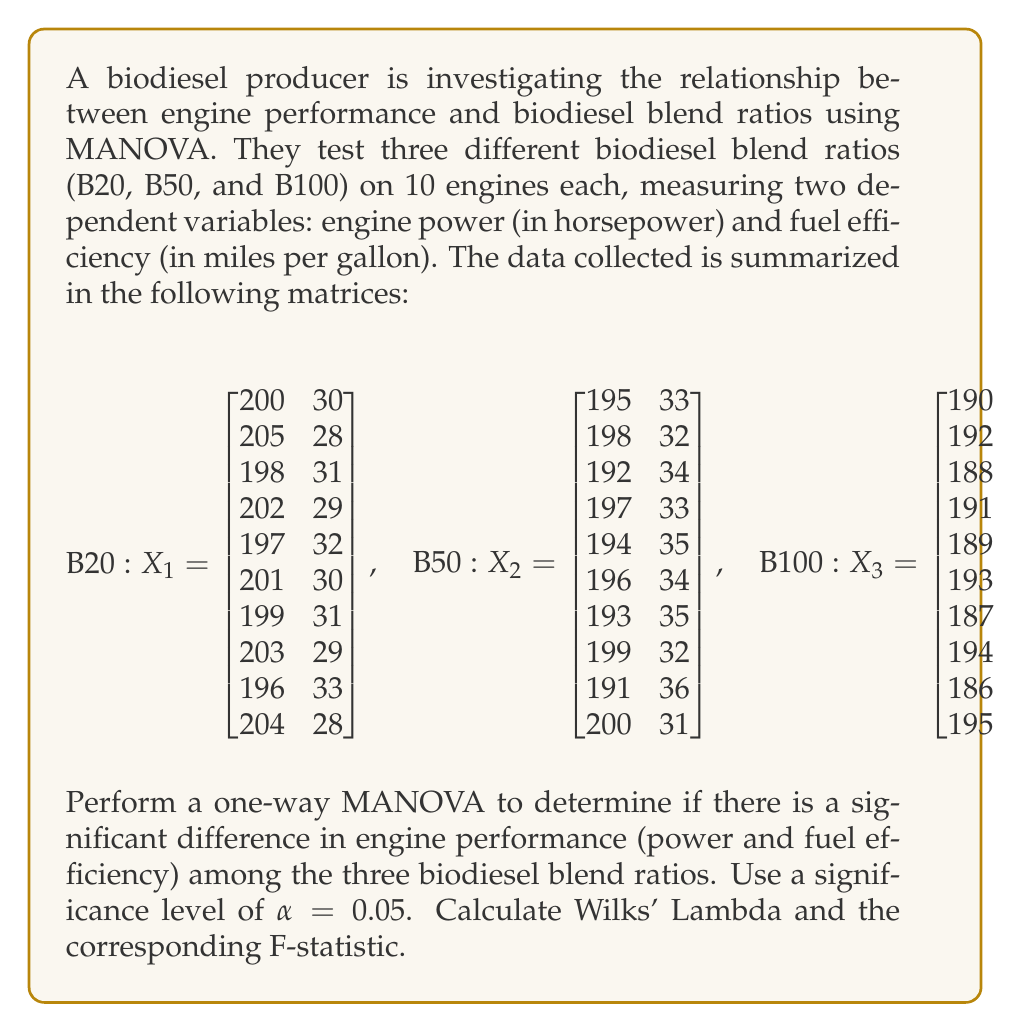Could you help me with this problem? To perform a one-way MANOVA, we need to follow these steps:

1. Calculate the within-group sum of squares and cross-products matrix (W)
2. Calculate the between-group sum of squares and cross-products matrix (B)
3. Calculate the total sum of squares and cross-products matrix (T)
4. Calculate Wilks' Lambda
5. Calculate the F-statistic
6. Compare the F-statistic to the critical value

Step 1: Calculate W

First, we need to calculate the mean vectors for each group:

$$\bar{X}_1 = \begin{bmatrix} 200.5 \\ 30.1 \end{bmatrix}, \quad
\bar{X}_2 = \begin{bmatrix} 195.5 \\ 33.5 \end{bmatrix}, \quad
\bar{X}_3 = \begin{bmatrix} 190.5 \\ 36.3 \end{bmatrix}$$

Now, we can calculate W:

$$W = \sum_{i=1}^3 \sum_{j=1}^{10} (X_{ij} - \bar{X}_i)(X_{ij} - \bar{X}_i)'$$

After calculations, we get:

$$W = \begin{bmatrix} 279.5 & -126.7 \\ -126.7 & 81.37 \end{bmatrix}$$

Step 2: Calculate B

Calculate the grand mean:

$$\bar{X} = \begin{bmatrix} 195.5 \\ 33.3 \end{bmatrix}$$

Now, calculate B:

$$B = \sum_{i=1}^3 10(\bar{X}_i - \bar{X})(\bar{X}_i - \bar{X})'$$

After calculations, we get:

$$B = \begin{bmatrix} 750 & -465 \\ -465 & 288.6 \end{bmatrix}$$

Step 3: Calculate T

$$T = W + B = \begin{bmatrix} 1029.5 & -591.7 \\ -591.7 & 369.97 \end{bmatrix}$$

Step 4: Calculate Wilks' Lambda

$$\Lambda = \frac{|W|}{|T|} = \frac{11424.19}{112996.72} = 0.1011$$

Step 5: Calculate the F-statistic

The F-statistic for Wilks' Lambda is:

$$F = \frac{1-\Lambda^{1/t}}{\Lambda^{1/t}} \cdot \frac{df_e - r + 1}{r}$$

Where:
$t = \min(p, df_h)$
$p = 2$ (number of dependent variables)
$df_h = 2$ (degrees of freedom for hypothesis)
$df_e = 27$ (degrees of freedom for error)
$r = 2$ (number of groups - 1)

$$F = \frac{1-0.1011^{1/2}}{0.1011^{1/2}} \cdot \frac{27 - 2 + 1}{2} = 52.37$$

Step 6: Compare to critical value

The critical F-value for $\alpha = 0.05$, $df_1 = 4$, and $df_2 = 52$ is approximately 2.55.

Since our calculated F-statistic (52.37) is greater than the critical value (2.55), we reject the null hypothesis.
Answer: Wilks' Lambda = 0.1011
F-statistic = 52.37
At $\alpha = 0.05$, we reject the null hypothesis. There is a significant difference in engine performance (power and fuel efficiency) among the three biodiesel blend ratios. 